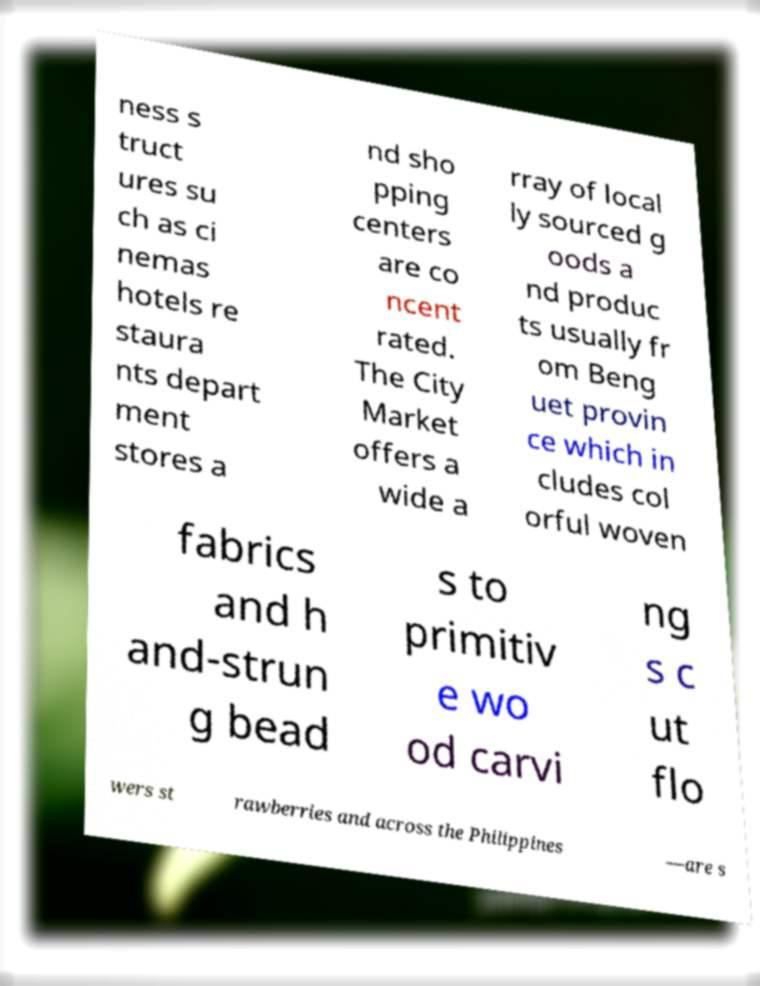Can you read and provide the text displayed in the image?This photo seems to have some interesting text. Can you extract and type it out for me? ness s truct ures su ch as ci nemas hotels re staura nts depart ment stores a nd sho pping centers are co ncent rated. The City Market offers a wide a rray of local ly sourced g oods a nd produc ts usually fr om Beng uet provin ce which in cludes col orful woven fabrics and h and-strun g bead s to primitiv e wo od carvi ng s c ut flo wers st rawberries and across the Philippines —are s 